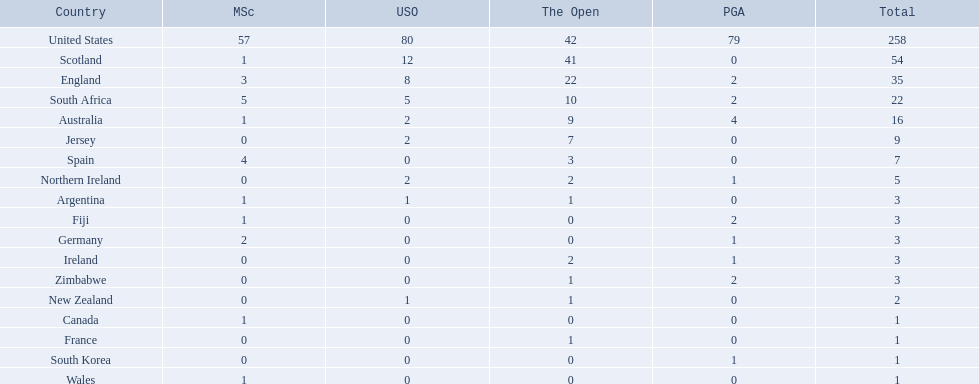Which of the countries listed are african? South Africa, Zimbabwe. Which of those has the least championship winning golfers? Zimbabwe. 